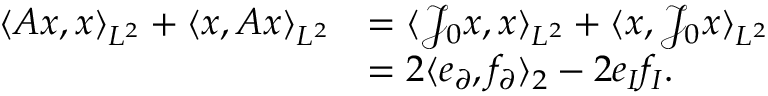<formula> <loc_0><loc_0><loc_500><loc_500>\begin{array} { r l } { \langle A x , x \rangle _ { L ^ { 2 } } + \langle x , A x \rangle _ { L ^ { 2 } } } & { = \langle \mathcal { J } _ { 0 } x , x \rangle _ { L ^ { 2 } } + \langle x , \mathcal { J } _ { 0 } x \rangle _ { L ^ { 2 } } } \\ & { = 2 \langle e _ { \partial } , f _ { \partial } \rangle _ { 2 } - 2 e _ { I } f _ { I } . } \end{array}</formula> 